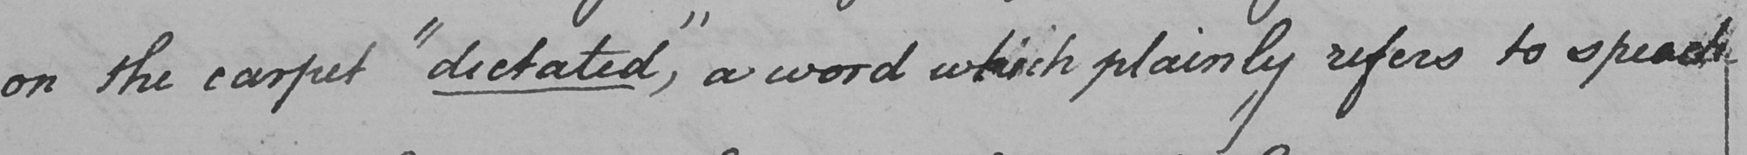Transcribe the text shown in this historical manuscript line. the carpet  " dictated , "  a word which plainly refers to speech 